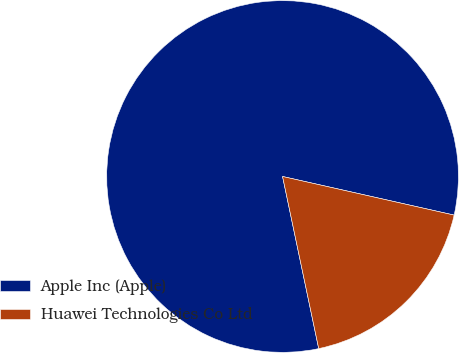Convert chart. <chart><loc_0><loc_0><loc_500><loc_500><pie_chart><fcel>Apple Inc (Apple)<fcel>Huawei Technologies Co Ltd<nl><fcel>81.82%<fcel>18.18%<nl></chart> 